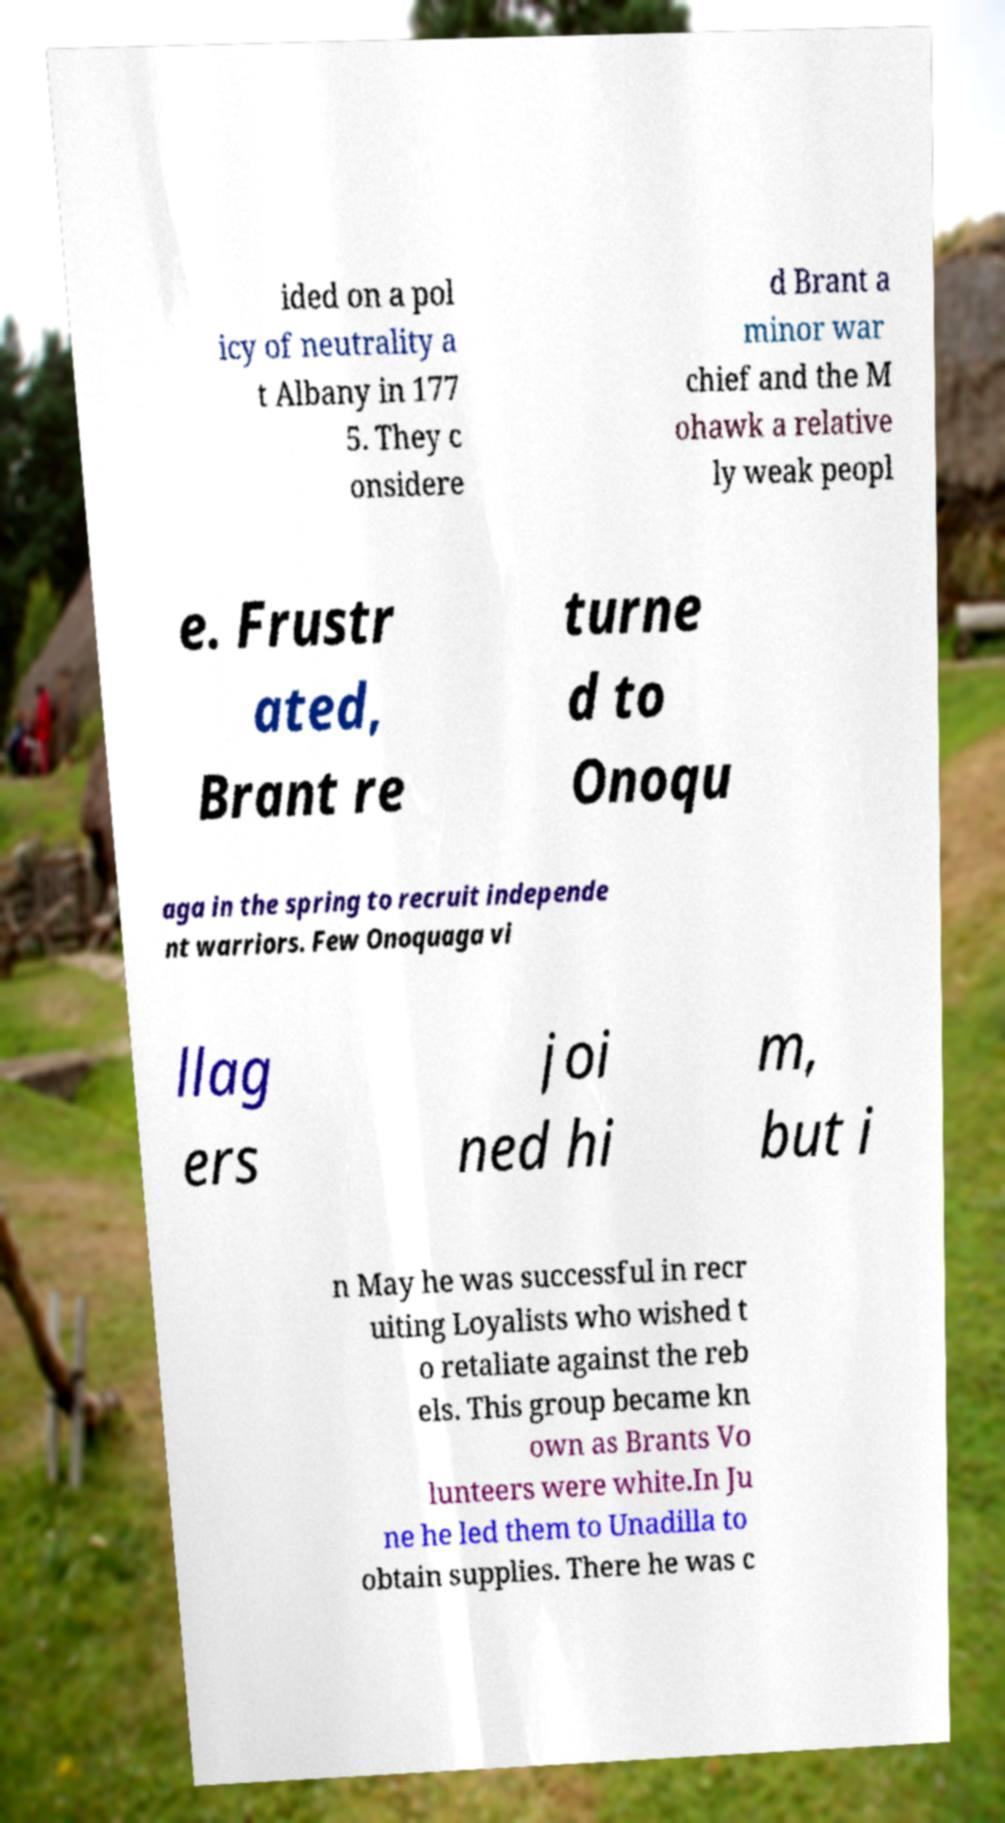Can you accurately transcribe the text from the provided image for me? ided on a pol icy of neutrality a t Albany in 177 5. They c onsidere d Brant a minor war chief and the M ohawk a relative ly weak peopl e. Frustr ated, Brant re turne d to Onoqu aga in the spring to recruit independe nt warriors. Few Onoquaga vi llag ers joi ned hi m, but i n May he was successful in recr uiting Loyalists who wished t o retaliate against the reb els. This group became kn own as Brants Vo lunteers were white.In Ju ne he led them to Unadilla to obtain supplies. There he was c 